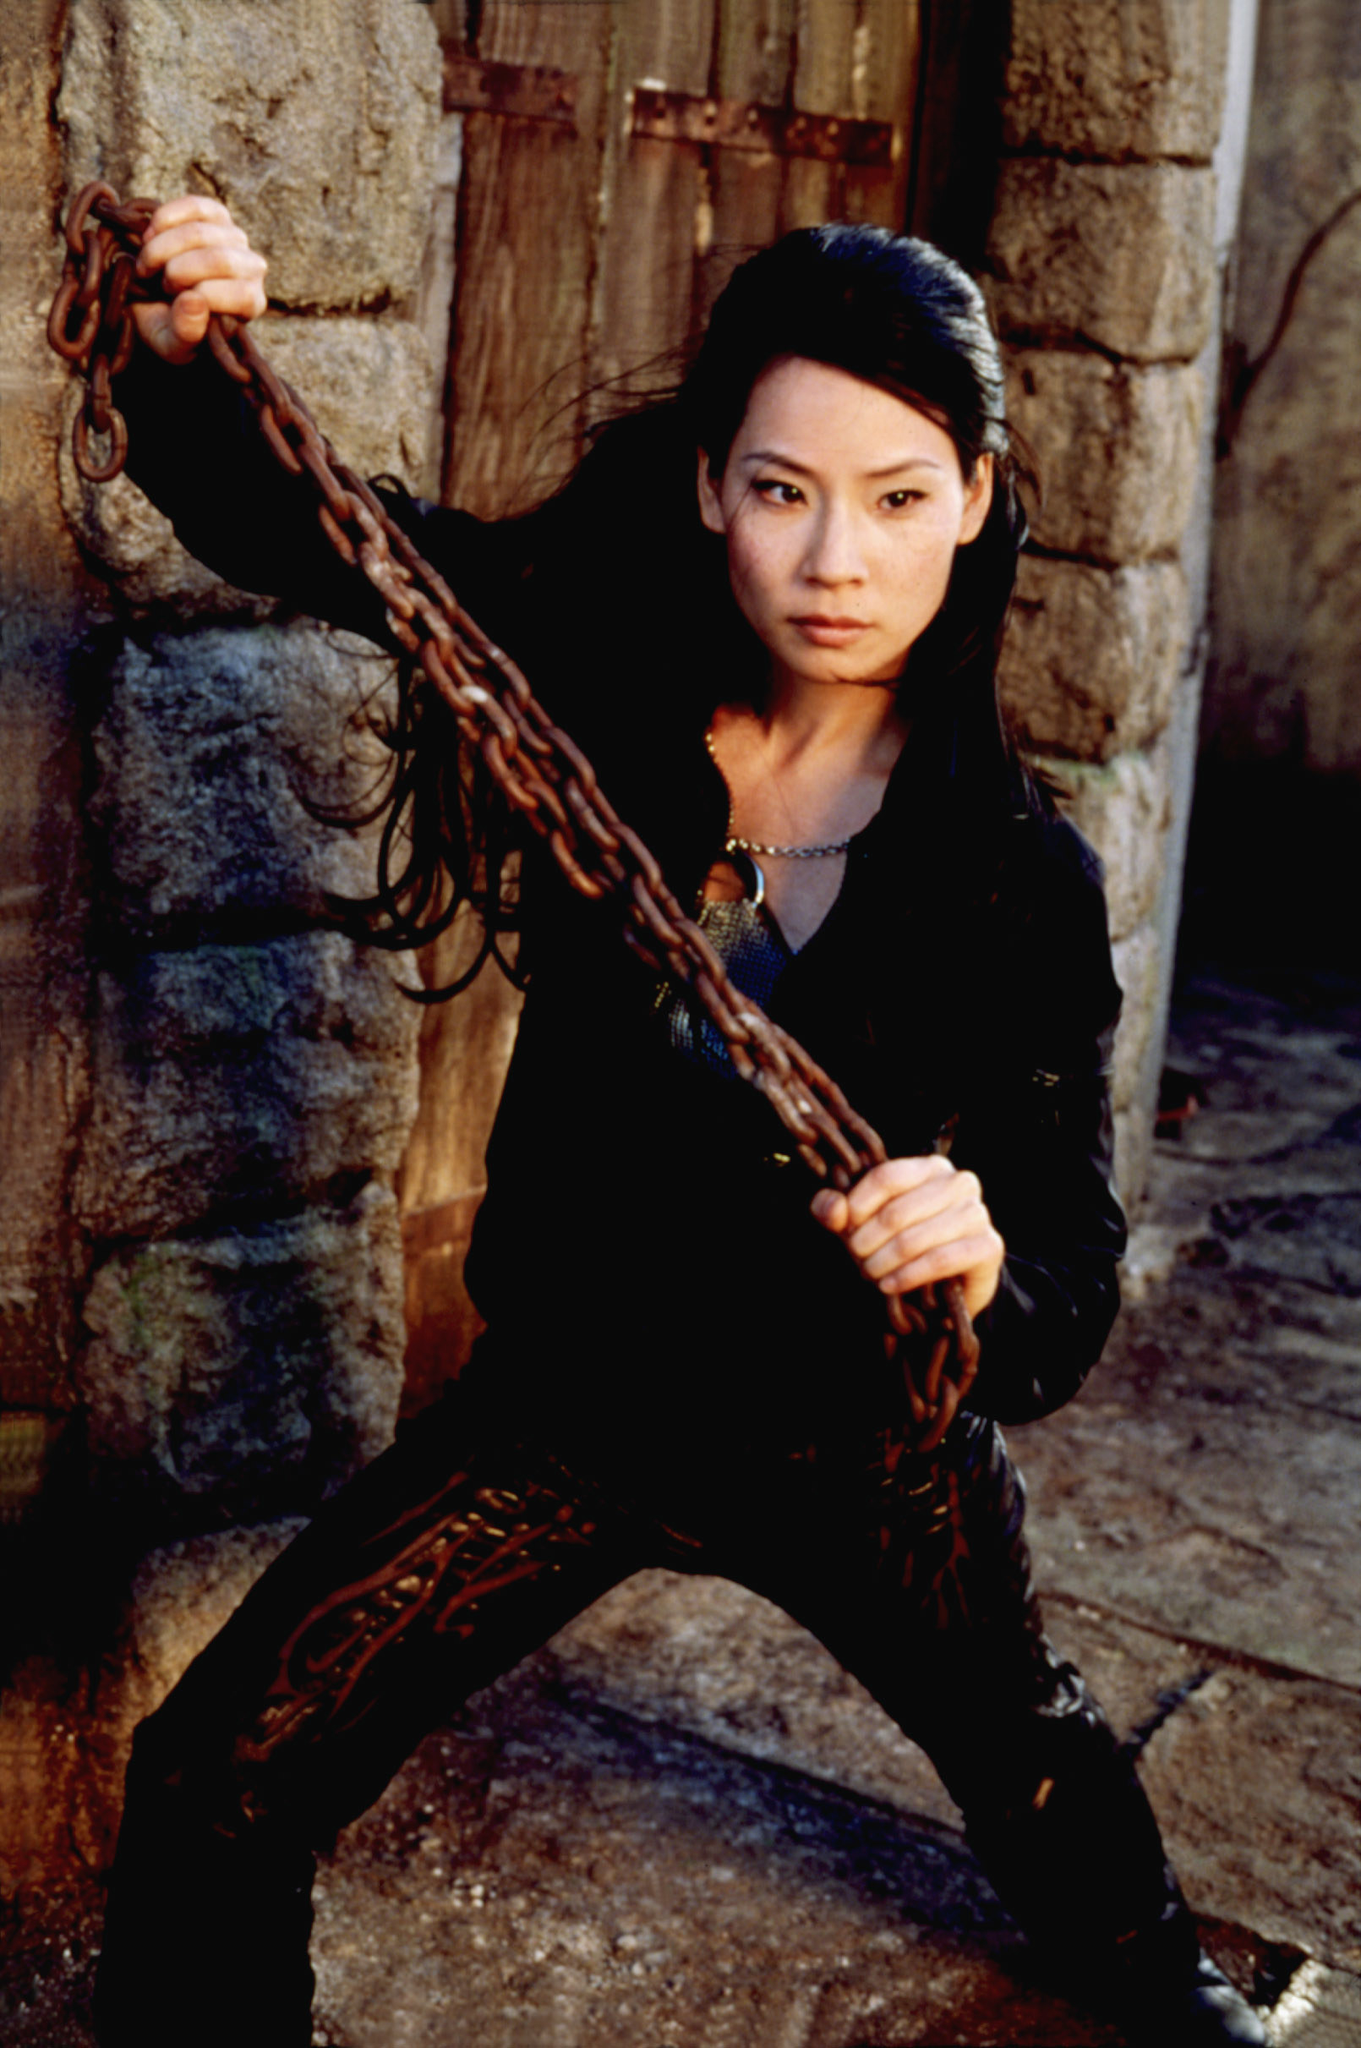What is happening in this scene? In this scene, the character appears to be in a moment of heightened tension or preparation. She is holding a chain with determination in a defensive, ready stance, suggesting she is expecting or preparing for an imminent confrontation. The setting, with its stone walls and wooden door, adds a rustic and perhaps historical or secluded atmosphere, augmenting the sense of urgency and action. Why is she holding the chain? The chain in her hand could symbolize readiness for combat or self-defense. It might be a tool or weapon she plans to use in the forthcoming conflict, showcasing her resourcefulness. The character's intense expression supports the idea that this is a serious, possibly dangerous situation, where she needs to be prepared for anything. Describe the setting in more detail. The setting of the image exudes an old-world charm mixed with a gritty realism. The backdrop features rough, aged stone walls, indicative of a structure that has faced the test of time. The wooden door shows signs of wear and tear, hinting at a long history. The ground appears worn and rugged, adding to the atmosphere of a place that has seen many events unfold. This rustic and somewhat foreboding setting enhances the character's poised stance, implying that she is in a place fraught with history and possibly danger. 